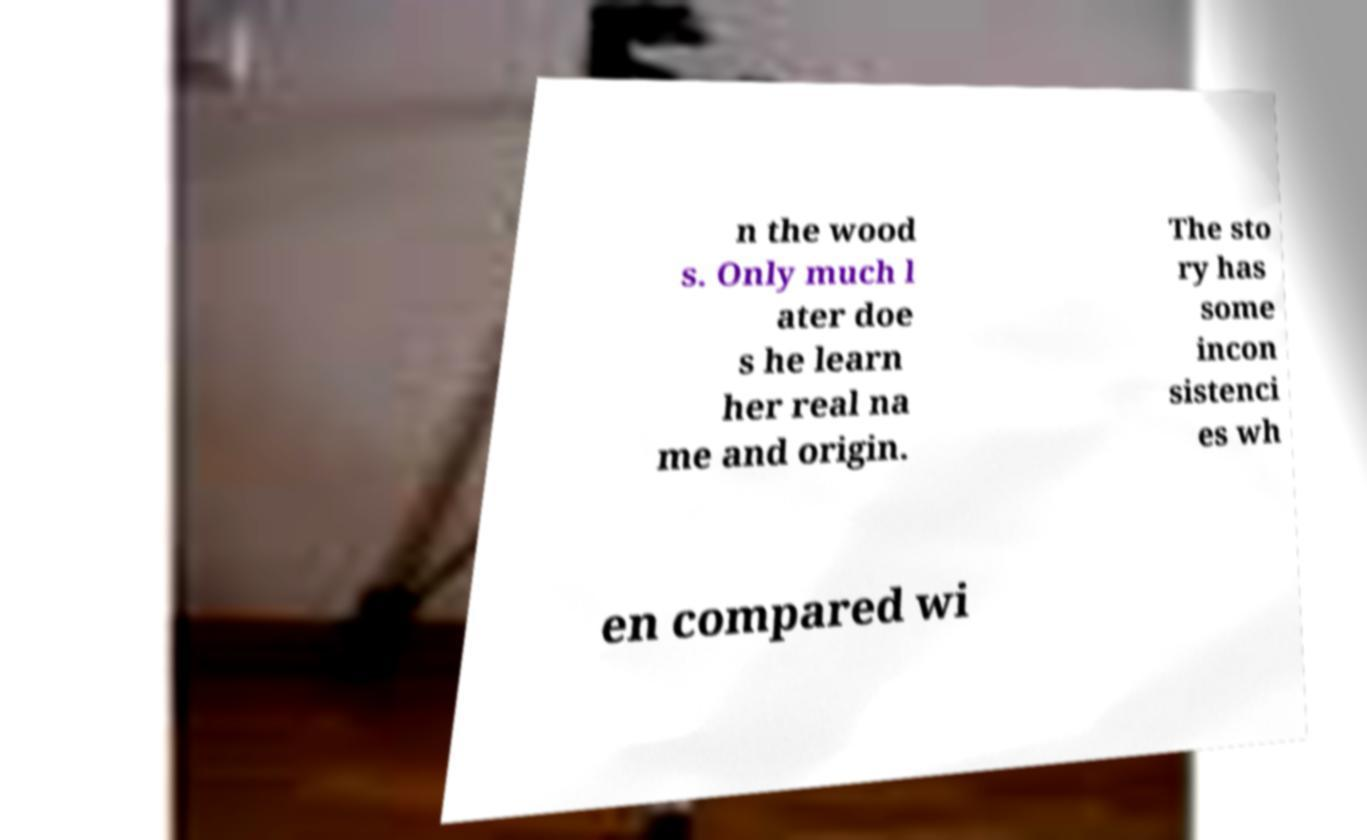There's text embedded in this image that I need extracted. Can you transcribe it verbatim? n the wood s. Only much l ater doe s he learn her real na me and origin. The sto ry has some incon sistenci es wh en compared wi 